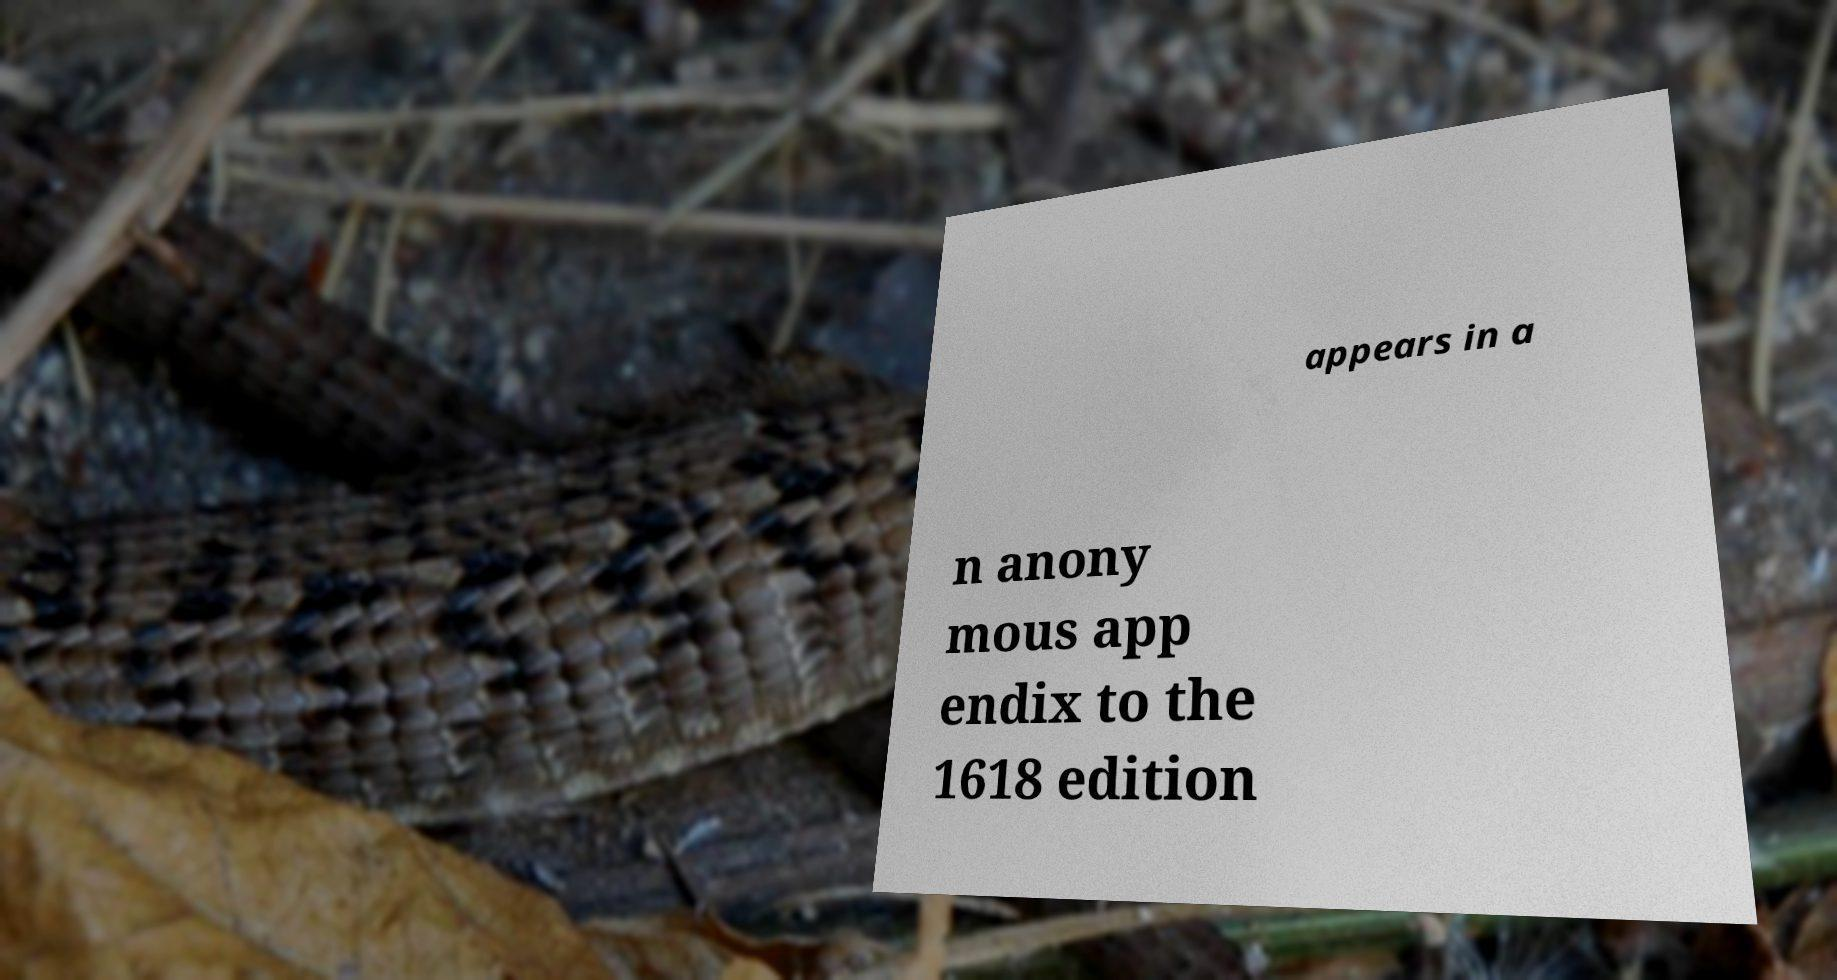There's text embedded in this image that I need extracted. Can you transcribe it verbatim? appears in a n anony mous app endix to the 1618 edition 